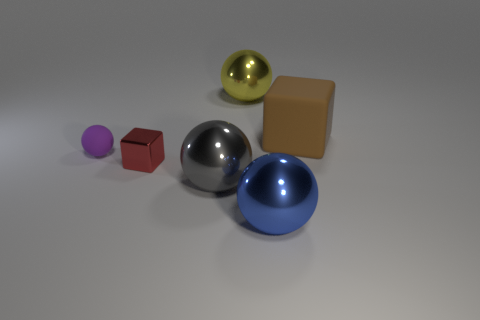Subtract 1 spheres. How many spheres are left? 3 Add 3 large green blocks. How many objects exist? 9 Subtract all spheres. How many objects are left? 2 Add 4 big gray shiny objects. How many big gray shiny objects are left? 5 Add 6 yellow spheres. How many yellow spheres exist? 7 Subtract 0 gray cubes. How many objects are left? 6 Subtract all big brown rubber blocks. Subtract all big blue objects. How many objects are left? 4 